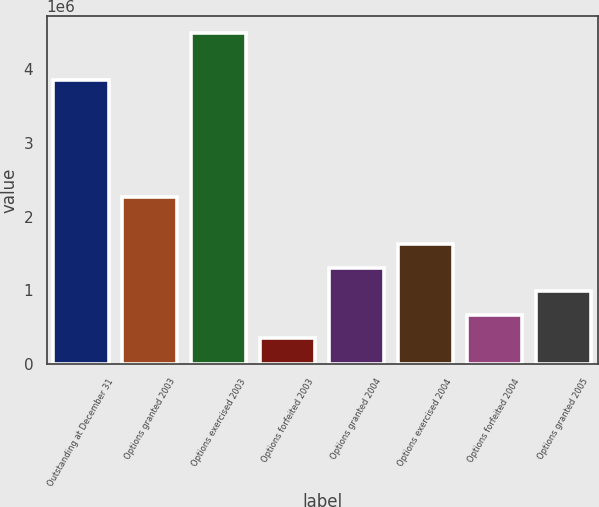Convert chart to OTSL. <chart><loc_0><loc_0><loc_500><loc_500><bar_chart><fcel>Outstanding at December 31<fcel>Options granted 2003<fcel>Options exercised 2003<fcel>Options forfeited 2003<fcel>Options granted 2004<fcel>Options exercised 2004<fcel>Options forfeited 2004<fcel>Options granted 2005<nl><fcel>3.85939e+06<fcel>2.26277e+06<fcel>4.49804e+06<fcel>346822<fcel>1.3048e+06<fcel>1.62412e+06<fcel>666146<fcel>985470<nl></chart> 